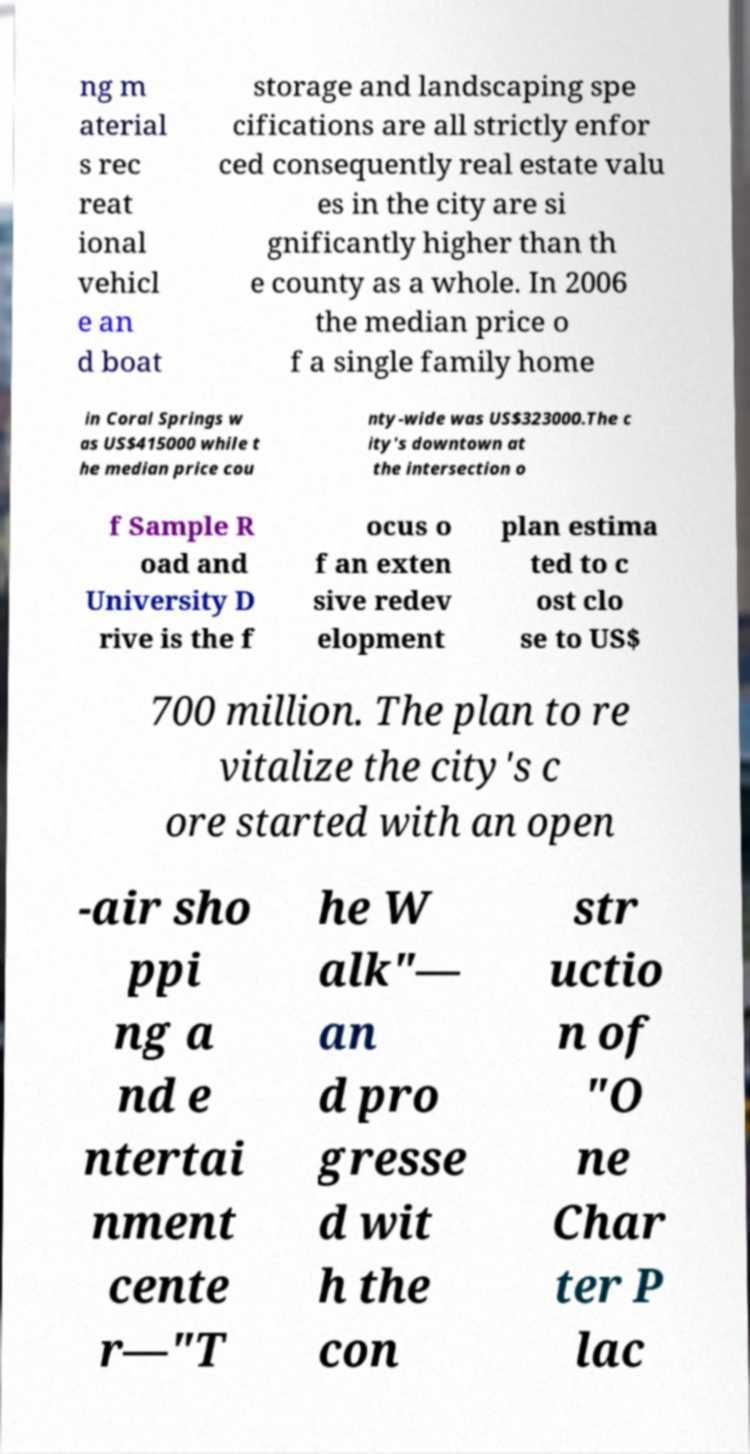Could you assist in decoding the text presented in this image and type it out clearly? ng m aterial s rec reat ional vehicl e an d boat storage and landscaping spe cifications are all strictly enfor ced consequently real estate valu es in the city are si gnificantly higher than th e county as a whole. In 2006 the median price o f a single family home in Coral Springs w as US$415000 while t he median price cou nty-wide was US$323000.The c ity's downtown at the intersection o f Sample R oad and University D rive is the f ocus o f an exten sive redev elopment plan estima ted to c ost clo se to US$ 700 million. The plan to re vitalize the city's c ore started with an open -air sho ppi ng a nd e ntertai nment cente r—"T he W alk"— an d pro gresse d wit h the con str uctio n of "O ne Char ter P lac 